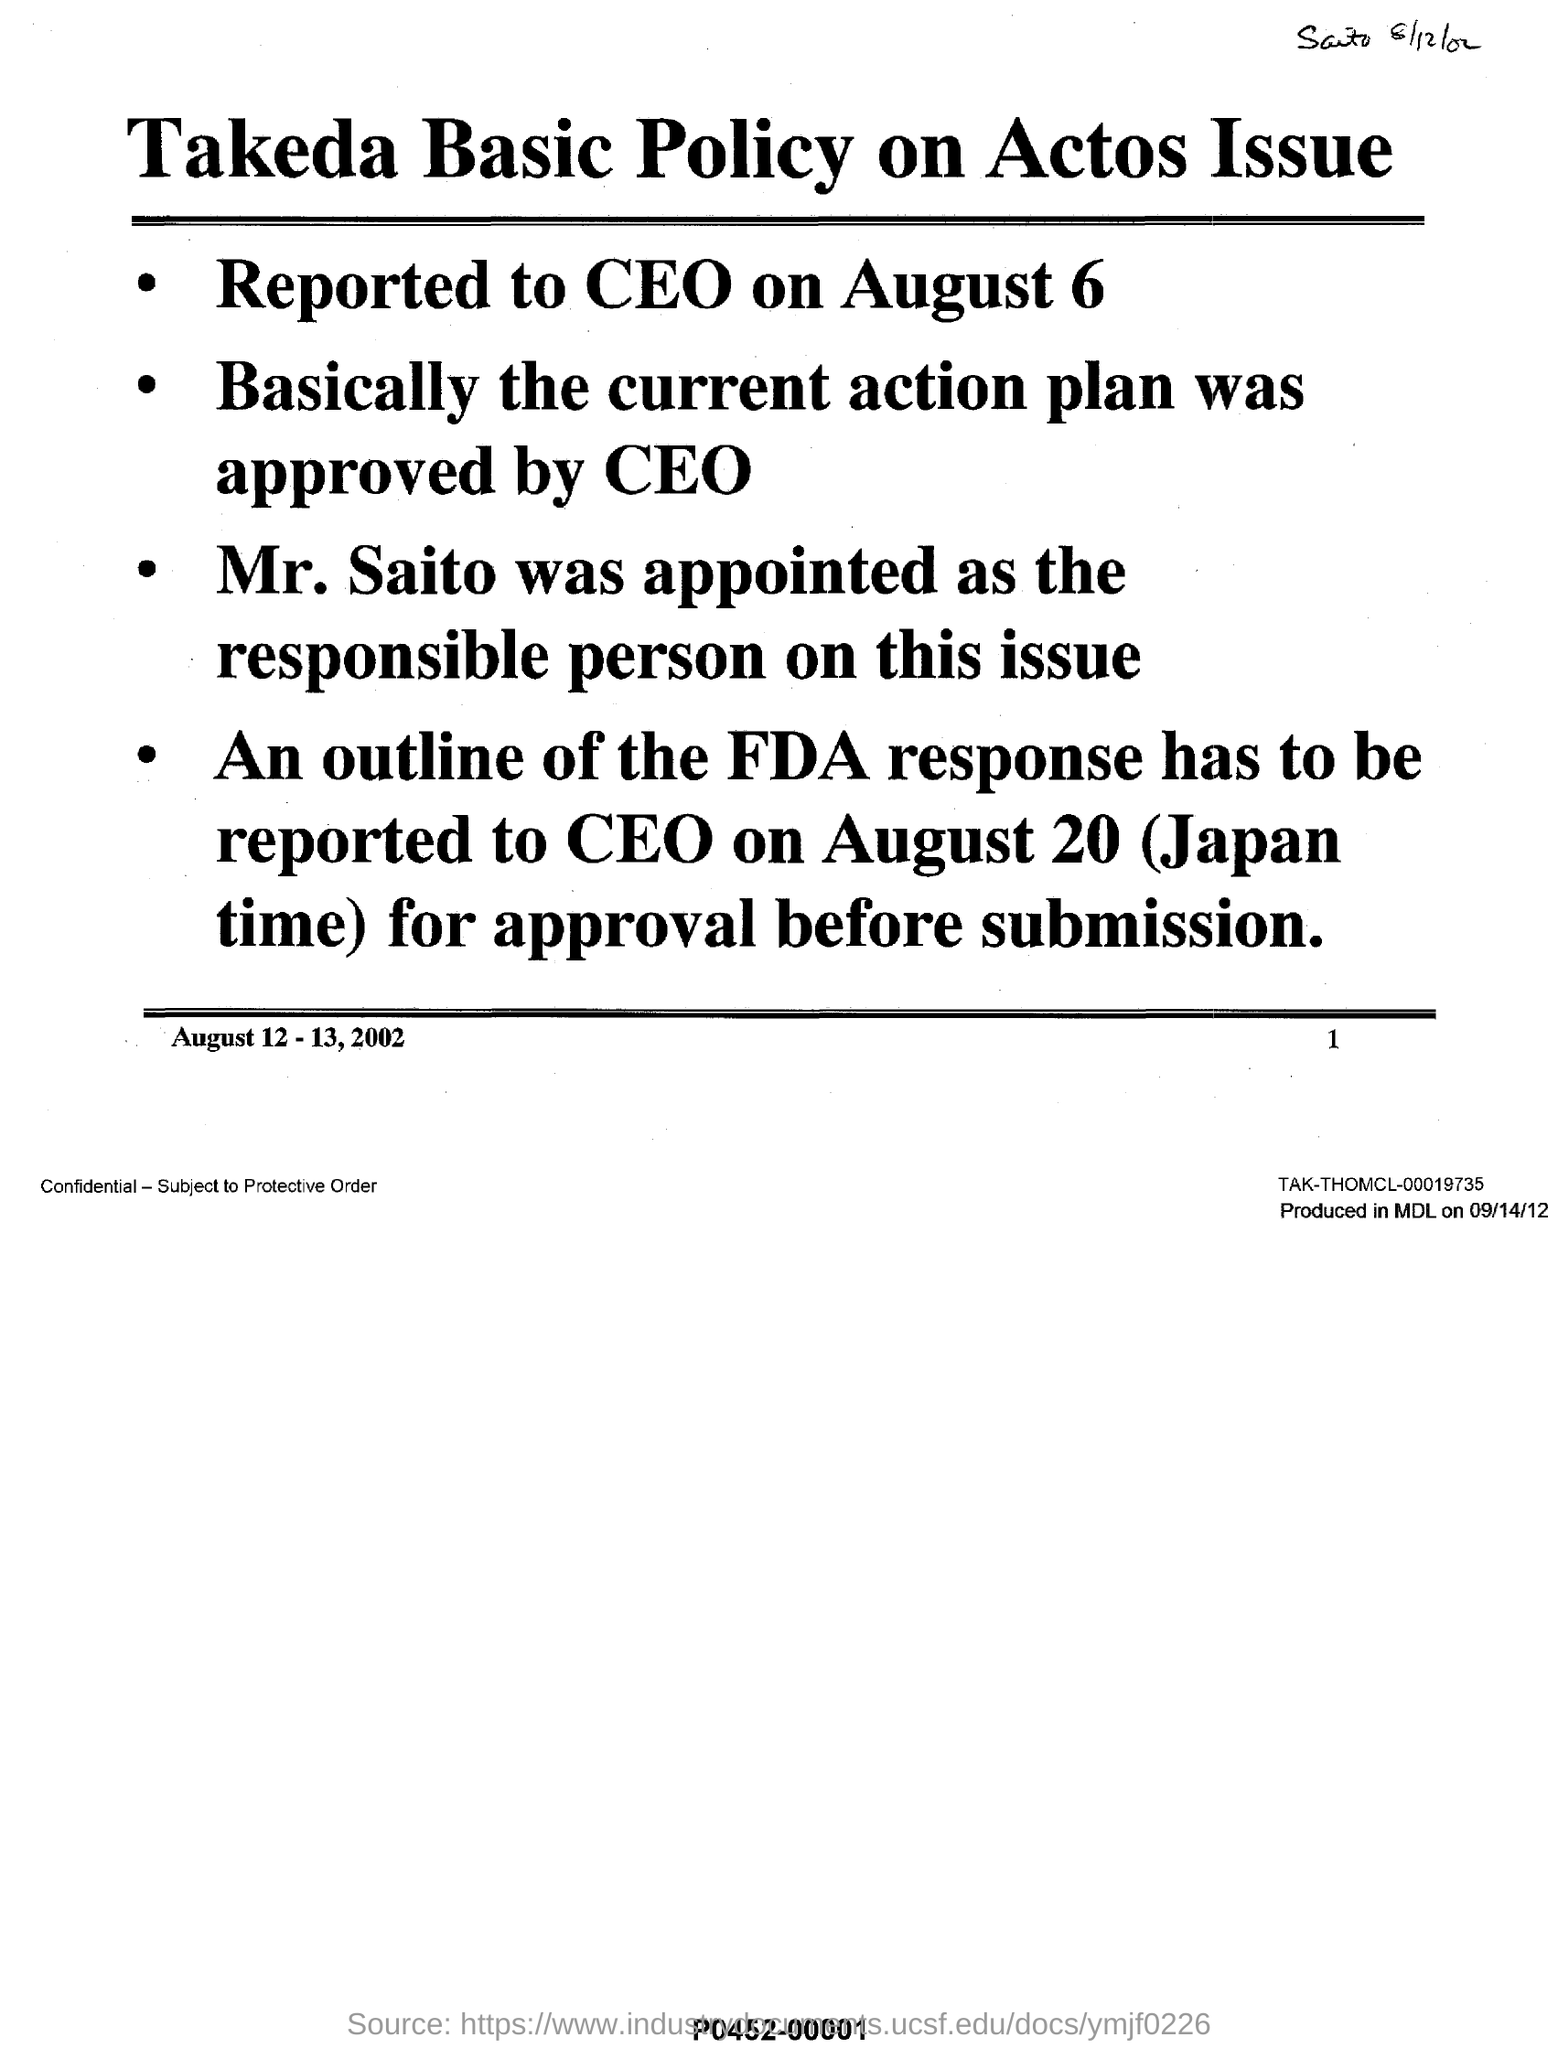Mention a couple of crucial points in this snapshot. The current action plan was approved by the CEO, essentially. TAKEDA'S BASIC POLICY IS THE NAME OF THE POLICY ON ACTOS ISSUE. MR. SAITO was appointed as the responsible person on this issue. The CEO is to be informed of an outline of the FDA response on August 20, at Japan time. On August 6th, the incident was reported to the CEO. 